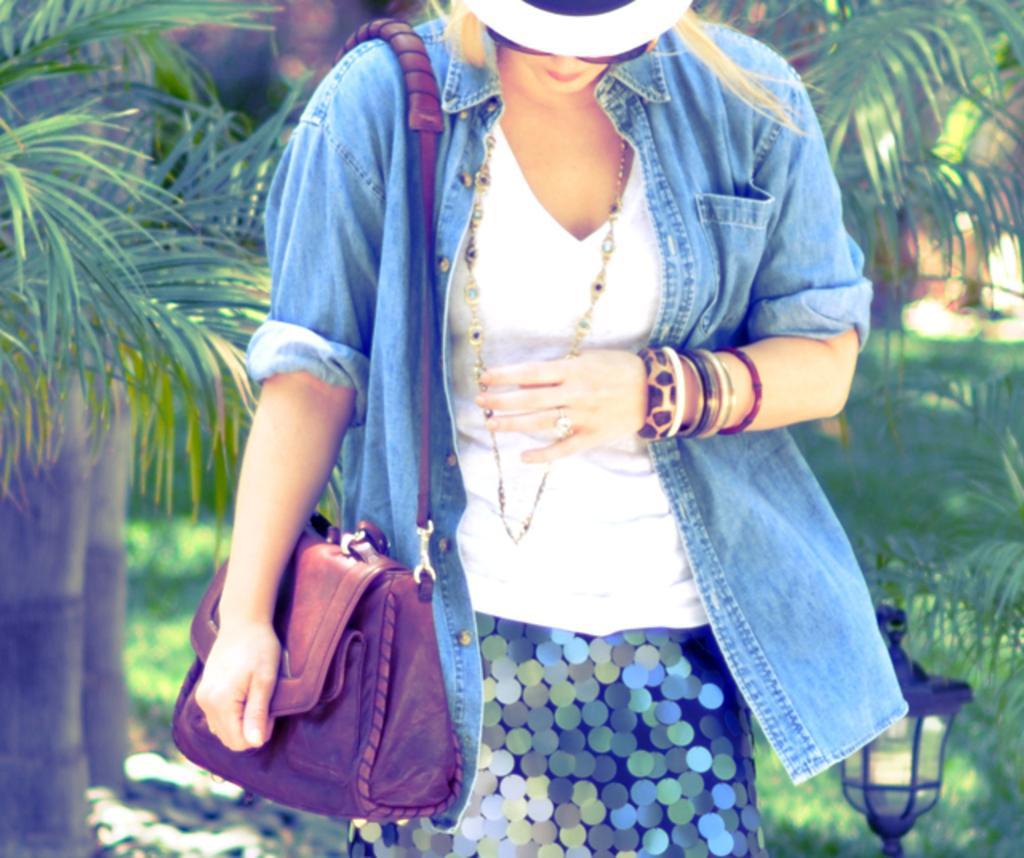Could you give a brief overview of what you see in this image? There is a woman in the picture. She is looking downwards. She is wearing a t shirt and a jeans shirt. A bag is hanged to her shoulder. Woman is also wearing a skirt. To her left hand there are some bangles and a ring to a finger. She is wearing a hat and a spectacles. In the background there is light and some trees are located. 